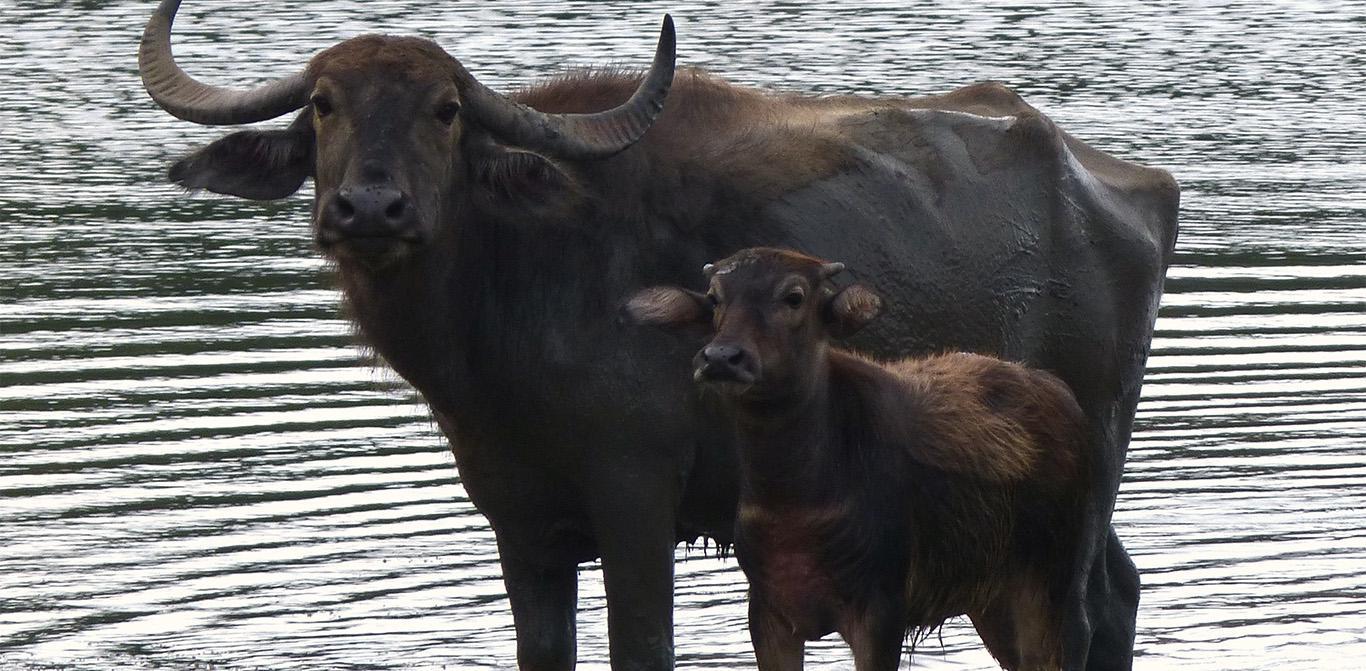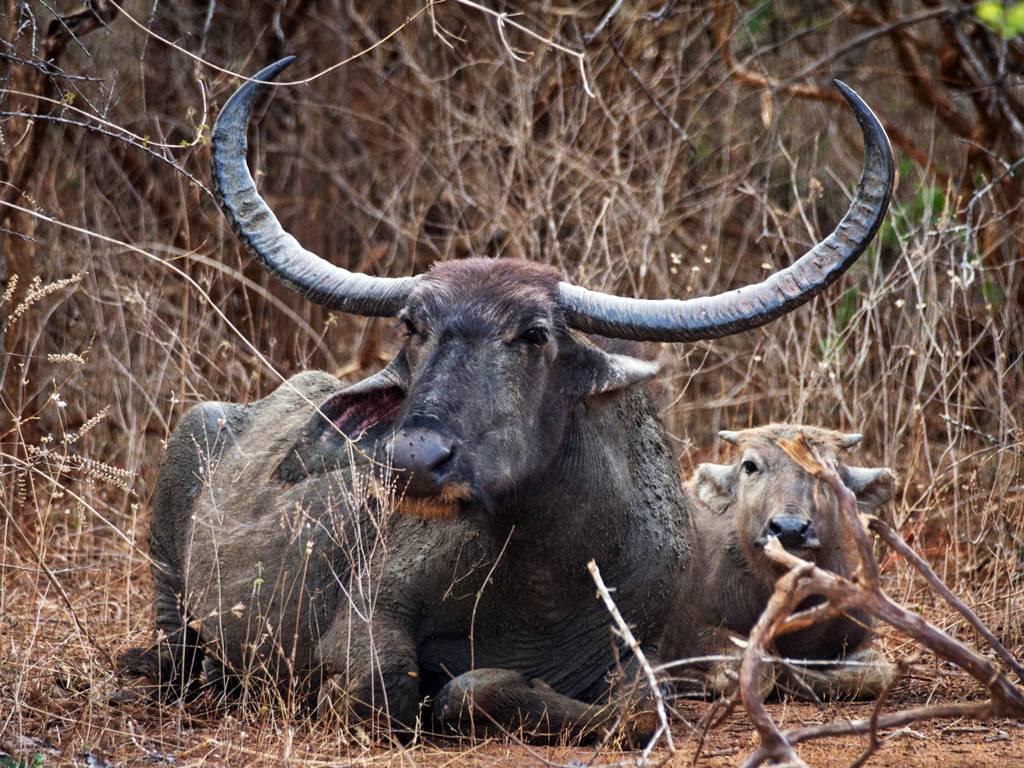The first image is the image on the left, the second image is the image on the right. For the images shown, is this caption "Two animals are standing in the water." true? Answer yes or no. Yes. 